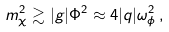<formula> <loc_0><loc_0><loc_500><loc_500>m _ { \chi } ^ { 2 } \gtrsim | g | \Phi ^ { 2 } \approx 4 | q | \omega _ { \phi } ^ { 2 } \, ,</formula> 